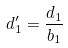<formula> <loc_0><loc_0><loc_500><loc_500>d _ { 1 } ^ { \prime } = \frac { d _ { 1 } } { b _ { 1 } }</formula> 